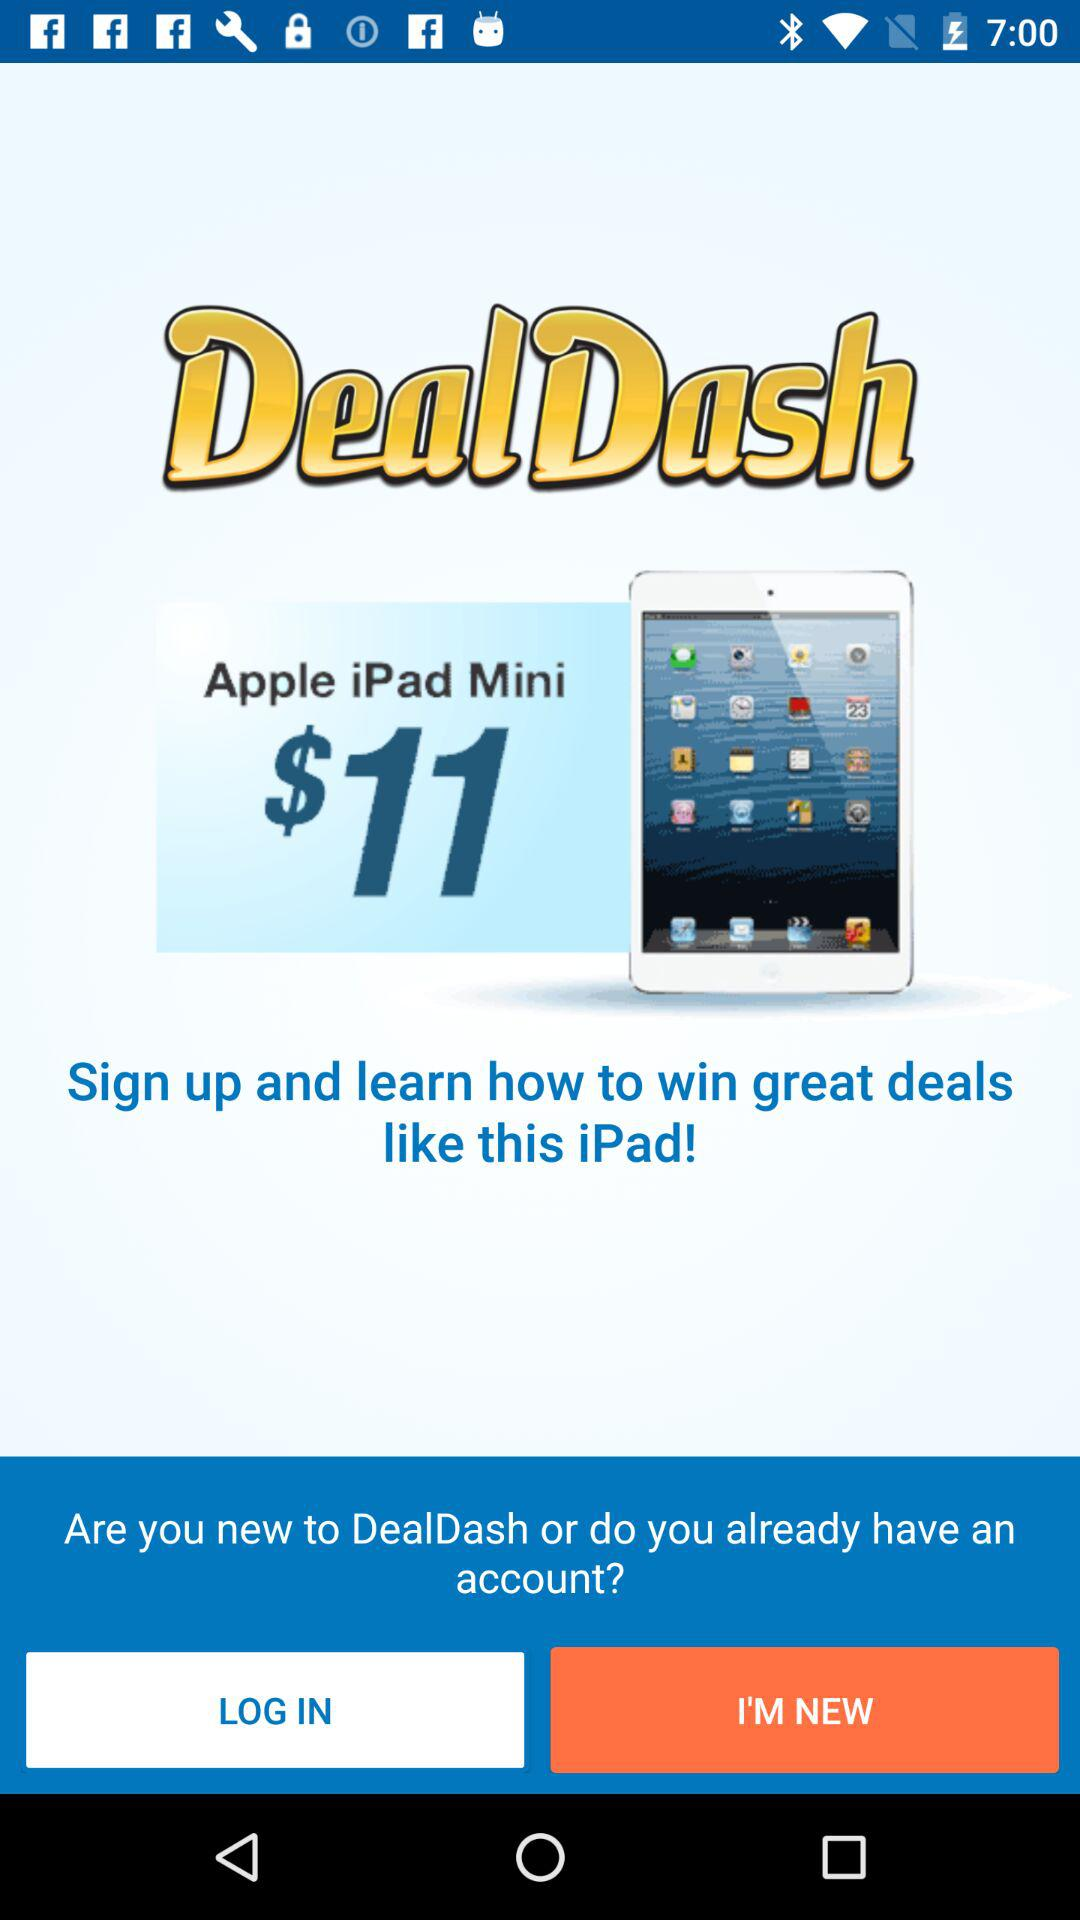What is the application name? The application name is "DealDash". 